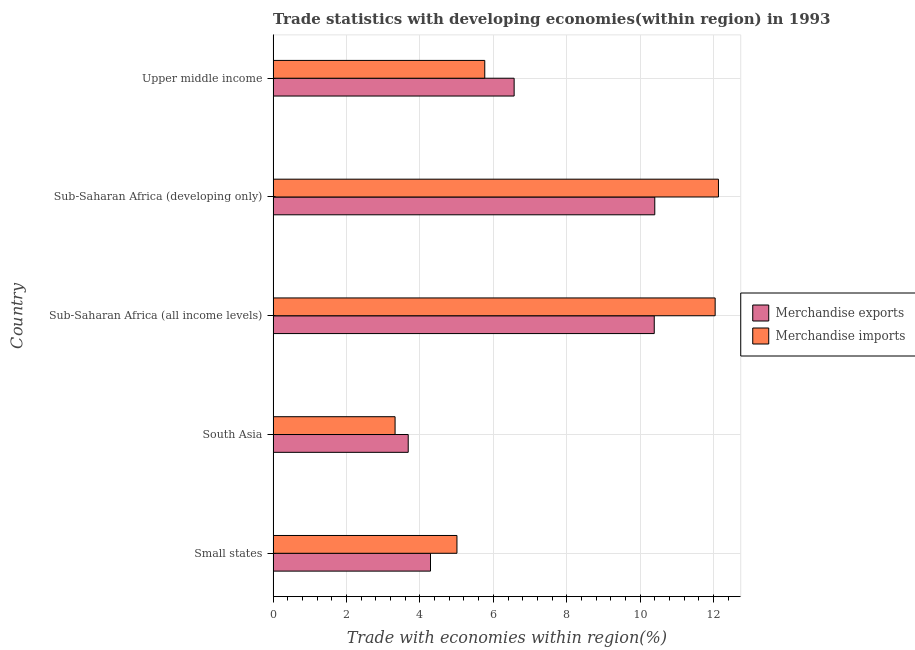How many groups of bars are there?
Offer a terse response. 5. Are the number of bars on each tick of the Y-axis equal?
Ensure brevity in your answer.  Yes. What is the label of the 3rd group of bars from the top?
Make the answer very short. Sub-Saharan Africa (all income levels). In how many cases, is the number of bars for a given country not equal to the number of legend labels?
Provide a succinct answer. 0. What is the merchandise exports in Sub-Saharan Africa (all income levels)?
Make the answer very short. 10.38. Across all countries, what is the maximum merchandise imports?
Your answer should be compact. 12.13. Across all countries, what is the minimum merchandise exports?
Your answer should be compact. 3.68. In which country was the merchandise imports maximum?
Keep it short and to the point. Sub-Saharan Africa (developing only). What is the total merchandise imports in the graph?
Keep it short and to the point. 38.28. What is the difference between the merchandise exports in Small states and that in Sub-Saharan Africa (developing only)?
Provide a succinct answer. -6.11. What is the difference between the merchandise imports in Small states and the merchandise exports in Sub-Saharan Africa (developing only)?
Provide a succinct answer. -5.39. What is the average merchandise imports per country?
Provide a succinct answer. 7.66. What is the difference between the merchandise exports and merchandise imports in South Asia?
Keep it short and to the point. 0.36. What is the ratio of the merchandise exports in Sub-Saharan Africa (developing only) to that in Upper middle income?
Ensure brevity in your answer.  1.58. Is the merchandise exports in South Asia less than that in Upper middle income?
Your response must be concise. Yes. Is the difference between the merchandise exports in Small states and Sub-Saharan Africa (all income levels) greater than the difference between the merchandise imports in Small states and Sub-Saharan Africa (all income levels)?
Provide a short and direct response. Yes. What is the difference between the highest and the second highest merchandise exports?
Provide a succinct answer. 0.01. What is the difference between the highest and the lowest merchandise imports?
Keep it short and to the point. 8.81. What does the 1st bar from the bottom in Sub-Saharan Africa (all income levels) represents?
Offer a very short reply. Merchandise exports. How many bars are there?
Provide a short and direct response. 10. Are all the bars in the graph horizontal?
Offer a very short reply. Yes. How many countries are there in the graph?
Give a very brief answer. 5. Are the values on the major ticks of X-axis written in scientific E-notation?
Offer a terse response. No. Does the graph contain grids?
Keep it short and to the point. Yes. Where does the legend appear in the graph?
Keep it short and to the point. Center right. How are the legend labels stacked?
Offer a very short reply. Vertical. What is the title of the graph?
Ensure brevity in your answer.  Trade statistics with developing economies(within region) in 1993. Does "Domestic Liabilities" appear as one of the legend labels in the graph?
Provide a short and direct response. No. What is the label or title of the X-axis?
Provide a succinct answer. Trade with economies within region(%). What is the Trade with economies within region(%) of Merchandise exports in Small states?
Ensure brevity in your answer.  4.29. What is the Trade with economies within region(%) in Merchandise imports in Small states?
Your answer should be compact. 5.01. What is the Trade with economies within region(%) in Merchandise exports in South Asia?
Ensure brevity in your answer.  3.68. What is the Trade with economies within region(%) in Merchandise imports in South Asia?
Provide a short and direct response. 3.32. What is the Trade with economies within region(%) in Merchandise exports in Sub-Saharan Africa (all income levels)?
Ensure brevity in your answer.  10.38. What is the Trade with economies within region(%) of Merchandise imports in Sub-Saharan Africa (all income levels)?
Keep it short and to the point. 12.04. What is the Trade with economies within region(%) of Merchandise exports in Sub-Saharan Africa (developing only)?
Offer a terse response. 10.4. What is the Trade with economies within region(%) in Merchandise imports in Sub-Saharan Africa (developing only)?
Provide a short and direct response. 12.13. What is the Trade with economies within region(%) in Merchandise exports in Upper middle income?
Your response must be concise. 6.57. What is the Trade with economies within region(%) of Merchandise imports in Upper middle income?
Provide a short and direct response. 5.77. Across all countries, what is the maximum Trade with economies within region(%) of Merchandise exports?
Provide a succinct answer. 10.4. Across all countries, what is the maximum Trade with economies within region(%) in Merchandise imports?
Make the answer very short. 12.13. Across all countries, what is the minimum Trade with economies within region(%) of Merchandise exports?
Your answer should be compact. 3.68. Across all countries, what is the minimum Trade with economies within region(%) in Merchandise imports?
Your answer should be very brief. 3.32. What is the total Trade with economies within region(%) of Merchandise exports in the graph?
Make the answer very short. 35.32. What is the total Trade with economies within region(%) of Merchandise imports in the graph?
Keep it short and to the point. 38.28. What is the difference between the Trade with economies within region(%) in Merchandise exports in Small states and that in South Asia?
Give a very brief answer. 0.61. What is the difference between the Trade with economies within region(%) of Merchandise imports in Small states and that in South Asia?
Offer a terse response. 1.69. What is the difference between the Trade with economies within region(%) in Merchandise exports in Small states and that in Sub-Saharan Africa (all income levels)?
Ensure brevity in your answer.  -6.1. What is the difference between the Trade with economies within region(%) of Merchandise imports in Small states and that in Sub-Saharan Africa (all income levels)?
Give a very brief answer. -7.04. What is the difference between the Trade with economies within region(%) of Merchandise exports in Small states and that in Sub-Saharan Africa (developing only)?
Give a very brief answer. -6.11. What is the difference between the Trade with economies within region(%) in Merchandise imports in Small states and that in Sub-Saharan Africa (developing only)?
Provide a short and direct response. -7.13. What is the difference between the Trade with economies within region(%) in Merchandise exports in Small states and that in Upper middle income?
Offer a very short reply. -2.28. What is the difference between the Trade with economies within region(%) in Merchandise imports in Small states and that in Upper middle income?
Provide a succinct answer. -0.76. What is the difference between the Trade with economies within region(%) of Merchandise exports in South Asia and that in Sub-Saharan Africa (all income levels)?
Offer a terse response. -6.7. What is the difference between the Trade with economies within region(%) of Merchandise imports in South Asia and that in Sub-Saharan Africa (all income levels)?
Provide a short and direct response. -8.72. What is the difference between the Trade with economies within region(%) in Merchandise exports in South Asia and that in Sub-Saharan Africa (developing only)?
Provide a short and direct response. -6.72. What is the difference between the Trade with economies within region(%) in Merchandise imports in South Asia and that in Sub-Saharan Africa (developing only)?
Give a very brief answer. -8.81. What is the difference between the Trade with economies within region(%) of Merchandise exports in South Asia and that in Upper middle income?
Ensure brevity in your answer.  -2.89. What is the difference between the Trade with economies within region(%) of Merchandise imports in South Asia and that in Upper middle income?
Keep it short and to the point. -2.44. What is the difference between the Trade with economies within region(%) in Merchandise exports in Sub-Saharan Africa (all income levels) and that in Sub-Saharan Africa (developing only)?
Your answer should be very brief. -0.01. What is the difference between the Trade with economies within region(%) of Merchandise imports in Sub-Saharan Africa (all income levels) and that in Sub-Saharan Africa (developing only)?
Give a very brief answer. -0.09. What is the difference between the Trade with economies within region(%) of Merchandise exports in Sub-Saharan Africa (all income levels) and that in Upper middle income?
Your answer should be compact. 3.82. What is the difference between the Trade with economies within region(%) of Merchandise imports in Sub-Saharan Africa (all income levels) and that in Upper middle income?
Your answer should be very brief. 6.28. What is the difference between the Trade with economies within region(%) of Merchandise exports in Sub-Saharan Africa (developing only) and that in Upper middle income?
Provide a succinct answer. 3.83. What is the difference between the Trade with economies within region(%) in Merchandise imports in Sub-Saharan Africa (developing only) and that in Upper middle income?
Keep it short and to the point. 6.37. What is the difference between the Trade with economies within region(%) in Merchandise exports in Small states and the Trade with economies within region(%) in Merchandise imports in Sub-Saharan Africa (all income levels)?
Your answer should be very brief. -7.76. What is the difference between the Trade with economies within region(%) of Merchandise exports in Small states and the Trade with economies within region(%) of Merchandise imports in Sub-Saharan Africa (developing only)?
Ensure brevity in your answer.  -7.85. What is the difference between the Trade with economies within region(%) in Merchandise exports in Small states and the Trade with economies within region(%) in Merchandise imports in Upper middle income?
Offer a terse response. -1.48. What is the difference between the Trade with economies within region(%) in Merchandise exports in South Asia and the Trade with economies within region(%) in Merchandise imports in Sub-Saharan Africa (all income levels)?
Make the answer very short. -8.36. What is the difference between the Trade with economies within region(%) in Merchandise exports in South Asia and the Trade with economies within region(%) in Merchandise imports in Sub-Saharan Africa (developing only)?
Offer a terse response. -8.45. What is the difference between the Trade with economies within region(%) in Merchandise exports in South Asia and the Trade with economies within region(%) in Merchandise imports in Upper middle income?
Your response must be concise. -2.09. What is the difference between the Trade with economies within region(%) of Merchandise exports in Sub-Saharan Africa (all income levels) and the Trade with economies within region(%) of Merchandise imports in Sub-Saharan Africa (developing only)?
Ensure brevity in your answer.  -1.75. What is the difference between the Trade with economies within region(%) in Merchandise exports in Sub-Saharan Africa (all income levels) and the Trade with economies within region(%) in Merchandise imports in Upper middle income?
Your answer should be compact. 4.62. What is the difference between the Trade with economies within region(%) of Merchandise exports in Sub-Saharan Africa (developing only) and the Trade with economies within region(%) of Merchandise imports in Upper middle income?
Provide a short and direct response. 4.63. What is the average Trade with economies within region(%) in Merchandise exports per country?
Ensure brevity in your answer.  7.06. What is the average Trade with economies within region(%) of Merchandise imports per country?
Provide a succinct answer. 7.66. What is the difference between the Trade with economies within region(%) in Merchandise exports and Trade with economies within region(%) in Merchandise imports in Small states?
Ensure brevity in your answer.  -0.72. What is the difference between the Trade with economies within region(%) of Merchandise exports and Trade with economies within region(%) of Merchandise imports in South Asia?
Your answer should be very brief. 0.36. What is the difference between the Trade with economies within region(%) in Merchandise exports and Trade with economies within region(%) in Merchandise imports in Sub-Saharan Africa (all income levels)?
Provide a short and direct response. -1.66. What is the difference between the Trade with economies within region(%) in Merchandise exports and Trade with economies within region(%) in Merchandise imports in Sub-Saharan Africa (developing only)?
Provide a succinct answer. -1.74. What is the difference between the Trade with economies within region(%) of Merchandise exports and Trade with economies within region(%) of Merchandise imports in Upper middle income?
Make the answer very short. 0.8. What is the ratio of the Trade with economies within region(%) in Merchandise exports in Small states to that in South Asia?
Keep it short and to the point. 1.16. What is the ratio of the Trade with economies within region(%) of Merchandise imports in Small states to that in South Asia?
Make the answer very short. 1.51. What is the ratio of the Trade with economies within region(%) in Merchandise exports in Small states to that in Sub-Saharan Africa (all income levels)?
Make the answer very short. 0.41. What is the ratio of the Trade with economies within region(%) of Merchandise imports in Small states to that in Sub-Saharan Africa (all income levels)?
Your answer should be very brief. 0.42. What is the ratio of the Trade with economies within region(%) of Merchandise exports in Small states to that in Sub-Saharan Africa (developing only)?
Your answer should be very brief. 0.41. What is the ratio of the Trade with economies within region(%) in Merchandise imports in Small states to that in Sub-Saharan Africa (developing only)?
Your answer should be very brief. 0.41. What is the ratio of the Trade with economies within region(%) of Merchandise exports in Small states to that in Upper middle income?
Offer a very short reply. 0.65. What is the ratio of the Trade with economies within region(%) in Merchandise imports in Small states to that in Upper middle income?
Provide a short and direct response. 0.87. What is the ratio of the Trade with economies within region(%) in Merchandise exports in South Asia to that in Sub-Saharan Africa (all income levels)?
Your answer should be very brief. 0.35. What is the ratio of the Trade with economies within region(%) in Merchandise imports in South Asia to that in Sub-Saharan Africa (all income levels)?
Keep it short and to the point. 0.28. What is the ratio of the Trade with economies within region(%) in Merchandise exports in South Asia to that in Sub-Saharan Africa (developing only)?
Your answer should be compact. 0.35. What is the ratio of the Trade with economies within region(%) in Merchandise imports in South Asia to that in Sub-Saharan Africa (developing only)?
Keep it short and to the point. 0.27. What is the ratio of the Trade with economies within region(%) of Merchandise exports in South Asia to that in Upper middle income?
Provide a short and direct response. 0.56. What is the ratio of the Trade with economies within region(%) of Merchandise imports in South Asia to that in Upper middle income?
Provide a succinct answer. 0.58. What is the ratio of the Trade with economies within region(%) in Merchandise exports in Sub-Saharan Africa (all income levels) to that in Upper middle income?
Keep it short and to the point. 1.58. What is the ratio of the Trade with economies within region(%) of Merchandise imports in Sub-Saharan Africa (all income levels) to that in Upper middle income?
Keep it short and to the point. 2.09. What is the ratio of the Trade with economies within region(%) of Merchandise exports in Sub-Saharan Africa (developing only) to that in Upper middle income?
Keep it short and to the point. 1.58. What is the ratio of the Trade with economies within region(%) in Merchandise imports in Sub-Saharan Africa (developing only) to that in Upper middle income?
Keep it short and to the point. 2.1. What is the difference between the highest and the second highest Trade with economies within region(%) of Merchandise exports?
Your answer should be very brief. 0.01. What is the difference between the highest and the second highest Trade with economies within region(%) in Merchandise imports?
Give a very brief answer. 0.09. What is the difference between the highest and the lowest Trade with economies within region(%) in Merchandise exports?
Ensure brevity in your answer.  6.72. What is the difference between the highest and the lowest Trade with economies within region(%) of Merchandise imports?
Your answer should be very brief. 8.81. 